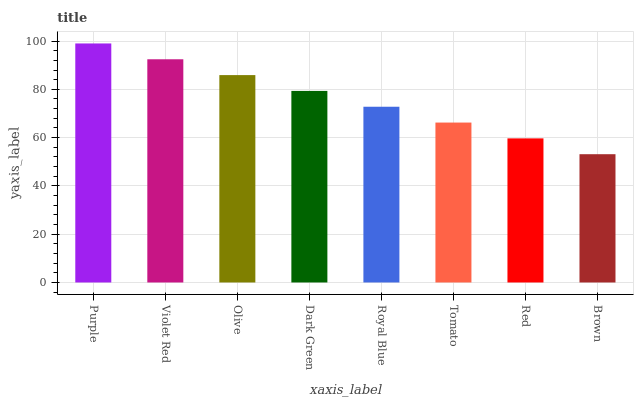Is Violet Red the minimum?
Answer yes or no. No. Is Violet Red the maximum?
Answer yes or no. No. Is Purple greater than Violet Red?
Answer yes or no. Yes. Is Violet Red less than Purple?
Answer yes or no. Yes. Is Violet Red greater than Purple?
Answer yes or no. No. Is Purple less than Violet Red?
Answer yes or no. No. Is Dark Green the high median?
Answer yes or no. Yes. Is Royal Blue the low median?
Answer yes or no. Yes. Is Red the high median?
Answer yes or no. No. Is Brown the low median?
Answer yes or no. No. 